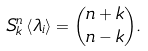Convert formula to latex. <formula><loc_0><loc_0><loc_500><loc_500>S _ { k } ^ { n } \left < \lambda _ { i } \right > = { n + k \choose n - k } .</formula> 